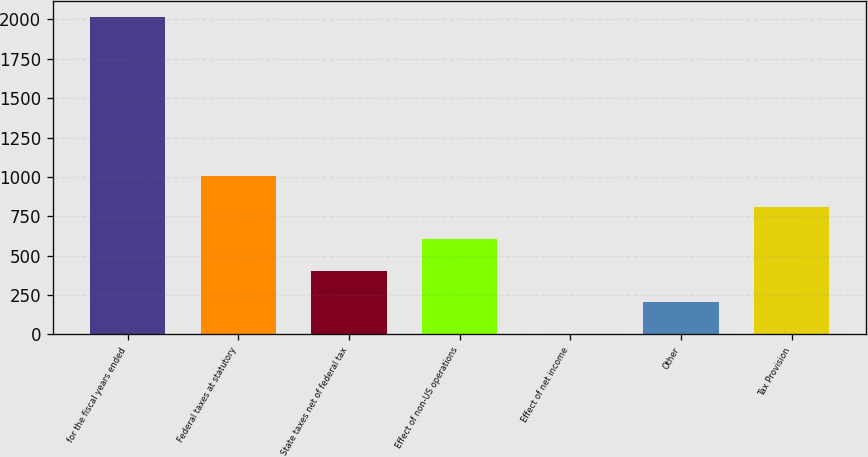Convert chart. <chart><loc_0><loc_0><loc_500><loc_500><bar_chart><fcel>for the fiscal years ended<fcel>Federal taxes at statutory<fcel>State taxes net of federal tax<fcel>Effect of non-US operations<fcel>Effect of net income<fcel>Other<fcel>Tax Provision<nl><fcel>2016<fcel>1008.2<fcel>403.52<fcel>605.08<fcel>0.4<fcel>201.96<fcel>806.64<nl></chart> 